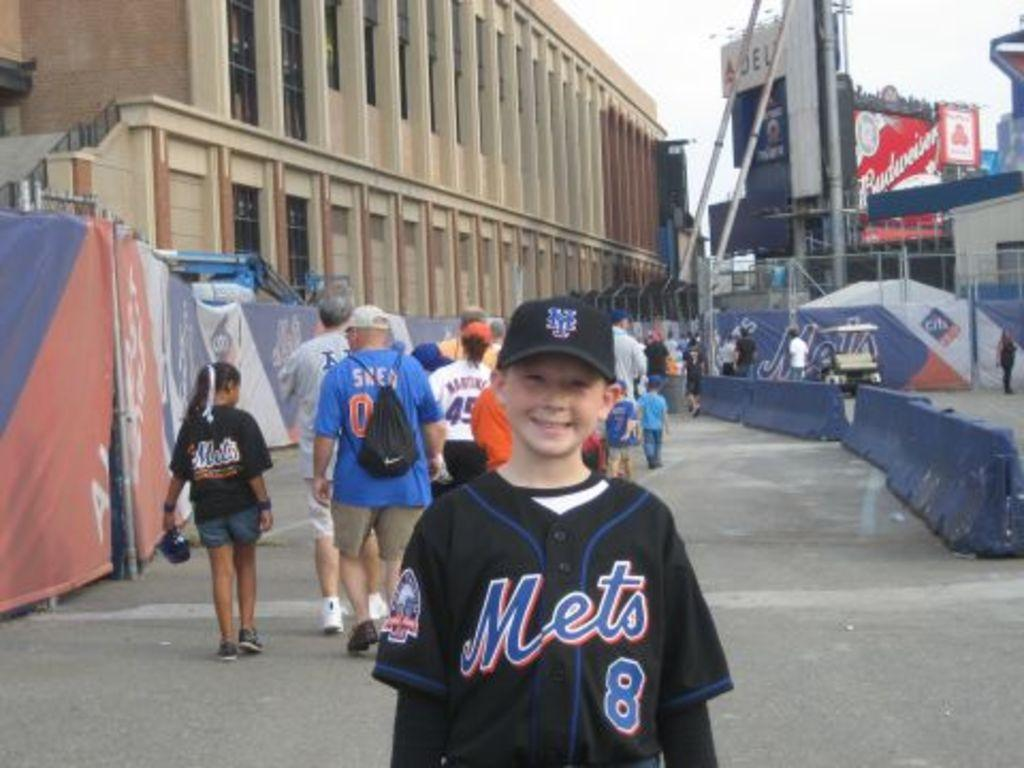<image>
Write a terse but informative summary of the picture. A boy is wearing a Mets uniform with a number 8 on it. 